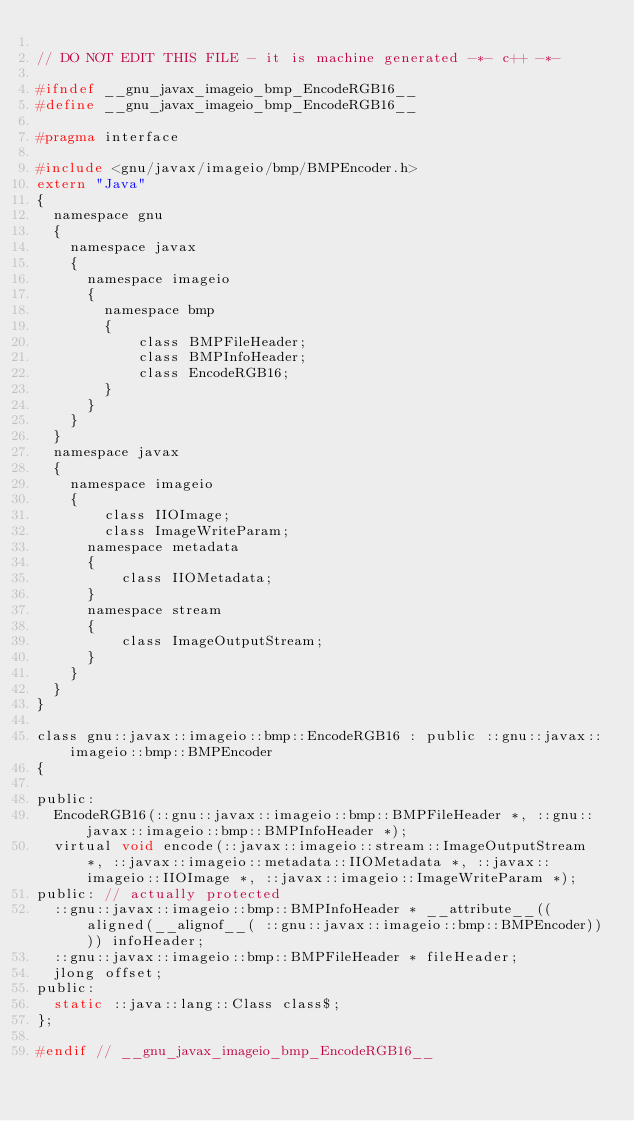Convert code to text. <code><loc_0><loc_0><loc_500><loc_500><_C_>
// DO NOT EDIT THIS FILE - it is machine generated -*- c++ -*-

#ifndef __gnu_javax_imageio_bmp_EncodeRGB16__
#define __gnu_javax_imageio_bmp_EncodeRGB16__

#pragma interface

#include <gnu/javax/imageio/bmp/BMPEncoder.h>
extern "Java"
{
  namespace gnu
  {
    namespace javax
    {
      namespace imageio
      {
        namespace bmp
        {
            class BMPFileHeader;
            class BMPInfoHeader;
            class EncodeRGB16;
        }
      }
    }
  }
  namespace javax
  {
    namespace imageio
    {
        class IIOImage;
        class ImageWriteParam;
      namespace metadata
      {
          class IIOMetadata;
      }
      namespace stream
      {
          class ImageOutputStream;
      }
    }
  }
}

class gnu::javax::imageio::bmp::EncodeRGB16 : public ::gnu::javax::imageio::bmp::BMPEncoder
{

public:
  EncodeRGB16(::gnu::javax::imageio::bmp::BMPFileHeader *, ::gnu::javax::imageio::bmp::BMPInfoHeader *);
  virtual void encode(::javax::imageio::stream::ImageOutputStream *, ::javax::imageio::metadata::IIOMetadata *, ::javax::imageio::IIOImage *, ::javax::imageio::ImageWriteParam *);
public: // actually protected
  ::gnu::javax::imageio::bmp::BMPInfoHeader * __attribute__((aligned(__alignof__( ::gnu::javax::imageio::bmp::BMPEncoder)))) infoHeader;
  ::gnu::javax::imageio::bmp::BMPFileHeader * fileHeader;
  jlong offset;
public:
  static ::java::lang::Class class$;
};

#endif // __gnu_javax_imageio_bmp_EncodeRGB16__
</code> 